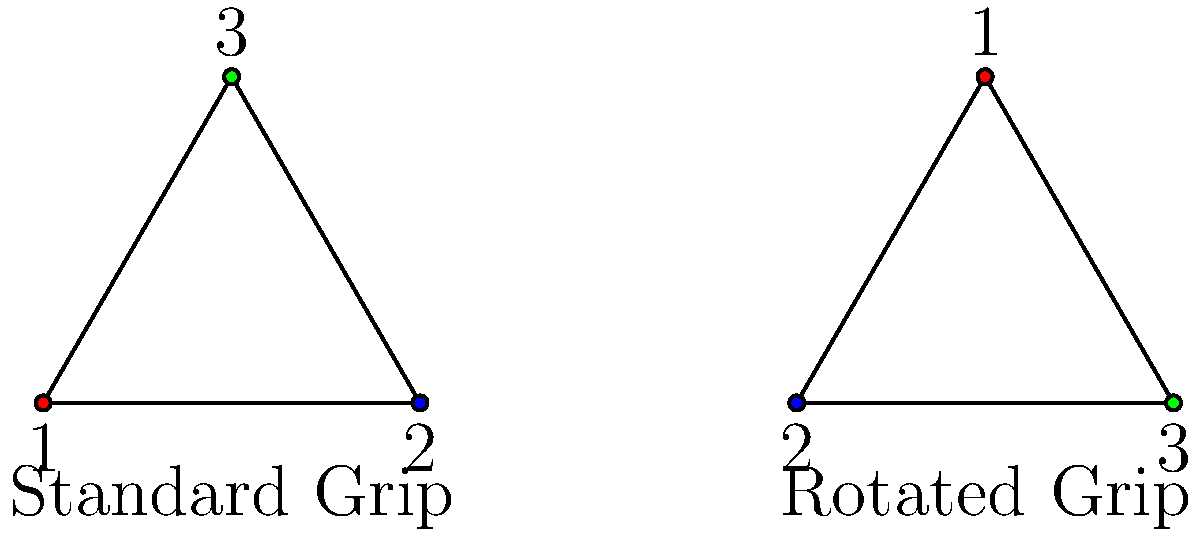As a pole vaulter, you're analyzing different grip techniques. The standard grip is represented by the permutation (1 2 3), while a rotated grip is represented by (1 3 2). What is the order of the group generated by these two permutations? Let's approach this step-by-step:

1) First, we need to understand what these permutations mean:
   (1 2 3) means 1 → 2, 2 → 3, 3 → 1
   (1 3 2) means 1 → 3, 3 → 2, 2 → 1

2) Now, let's generate all possible combinations of these permutations:
   
   Identity: (1)
   Standard grip: (1 2 3)
   Rotated grip: (1 3 2)
   
   (1 2 3) * (1 3 2) = (2 3 1)
   (1 3 2) * (1 2 3) = (3 1 2)
   
3) We can see that we've generated all possible permutations of 3 elements.

4) The number of permutations of n elements is n!. In this case, 3! = 6.

5) Therefore, the group generated by these two permutations is the symmetric group S₃, which has order 6.

This group represents all possible ways to rearrange the three hand positions on the pole, which is relevant to analyzing different grip techniques in pole vaulting.
Answer: 6 